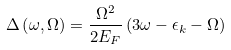<formula> <loc_0><loc_0><loc_500><loc_500>\Delta \left ( \omega , \Omega \right ) = \frac { \Omega ^ { 2 } } { 2 E _ { F } } \left ( 3 \omega - \epsilon _ { k } - \Omega \right )</formula> 